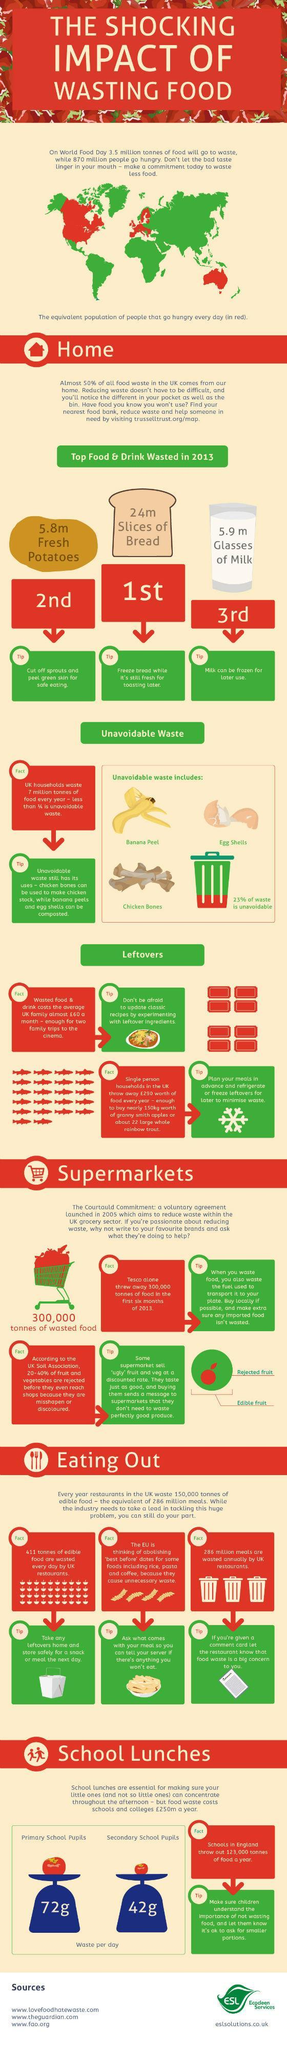What is the quantity of milk wasted in UK in 2013?
Answer the question with a short phrase. 5.9 m How much food is wasted per day by secondary school pupils in UK? 42g Which is the top wasted drink in UK in 2013? Milk Which is the top wasted food in UK in 2013? Bread What percentage of waste is avoidable in UK households in 2013? 77% What is the quantity of fresh potatoes wasted in UK in 2013? 5.8m How much food is wasted per day by primary school pupils in UK? 72g 